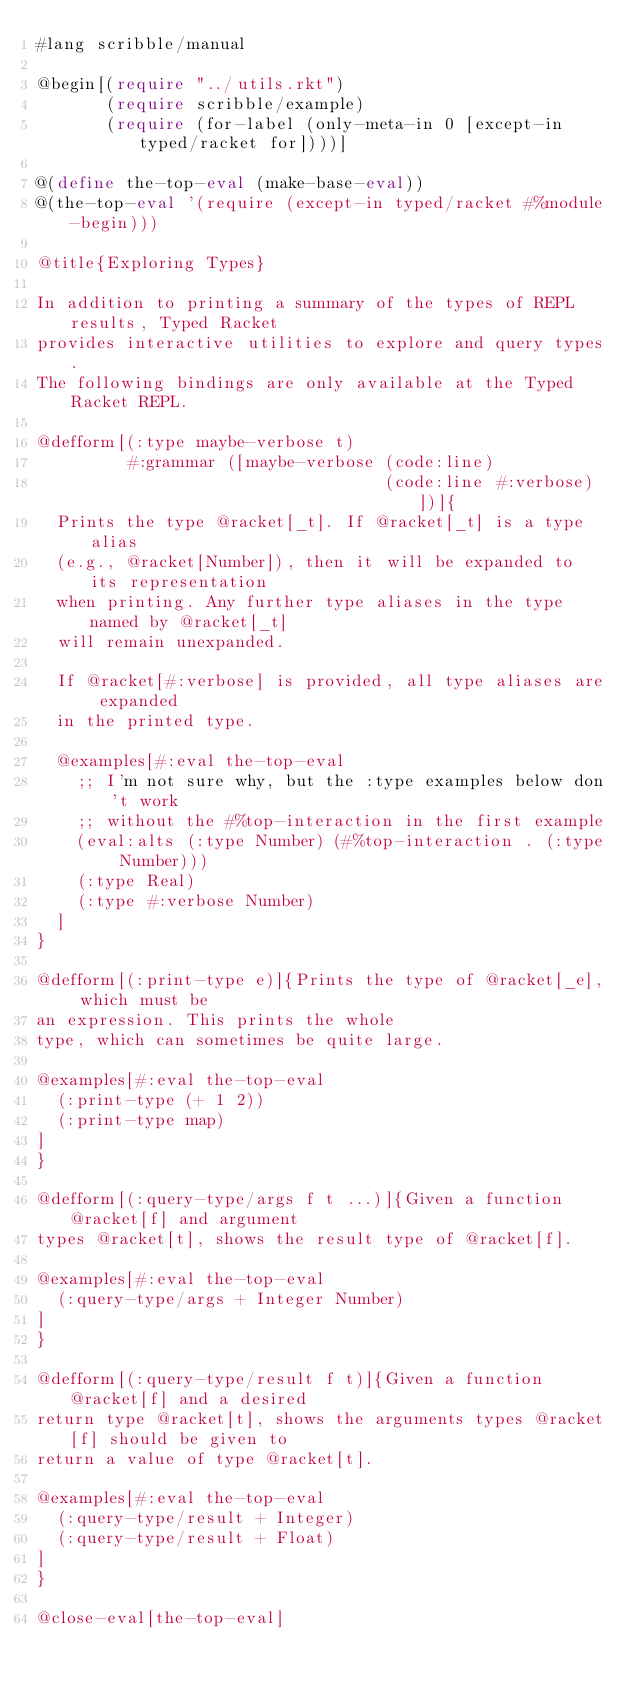Convert code to text. <code><loc_0><loc_0><loc_500><loc_500><_Racket_>#lang scribble/manual

@begin[(require "../utils.rkt")
       (require scribble/example)
       (require (for-label (only-meta-in 0 [except-in typed/racket for])))]

@(define the-top-eval (make-base-eval))
@(the-top-eval '(require (except-in typed/racket #%module-begin)))

@title{Exploring Types}

In addition to printing a summary of the types of REPL results, Typed Racket
provides interactive utilities to explore and query types.
The following bindings are only available at the Typed Racket REPL.

@defform[(:type maybe-verbose t)
         #:grammar ([maybe-verbose (code:line)
                                   (code:line #:verbose)])]{
  Prints the type @racket[_t]. If @racket[_t] is a type alias
  (e.g., @racket[Number]), then it will be expanded to its representation
  when printing. Any further type aliases in the type named by @racket[_t]
  will remain unexpanded.

  If @racket[#:verbose] is provided, all type aliases are expanded
  in the printed type.

  @examples[#:eval the-top-eval
    ;; I'm not sure why, but the :type examples below don't work
    ;; without the #%top-interaction in the first example
    (eval:alts (:type Number) (#%top-interaction . (:type Number)))
    (:type Real)
    (:type #:verbose Number)
  ]
}

@defform[(:print-type e)]{Prints the type of @racket[_e], which must be
an expression. This prints the whole
type, which can sometimes be quite large.

@examples[#:eval the-top-eval
  (:print-type (+ 1 2))
  (:print-type map)
]
}

@defform[(:query-type/args f t ...)]{Given a function @racket[f] and argument
types @racket[t], shows the result type of @racket[f].

@examples[#:eval the-top-eval
  (:query-type/args + Integer Number)
]
}

@defform[(:query-type/result f t)]{Given a function @racket[f] and a desired
return type @racket[t], shows the arguments types @racket[f] should be given to
return a value of type @racket[t].

@examples[#:eval the-top-eval
  (:query-type/result + Integer)
  (:query-type/result + Float)
]
}

@close-eval[the-top-eval]

</code> 